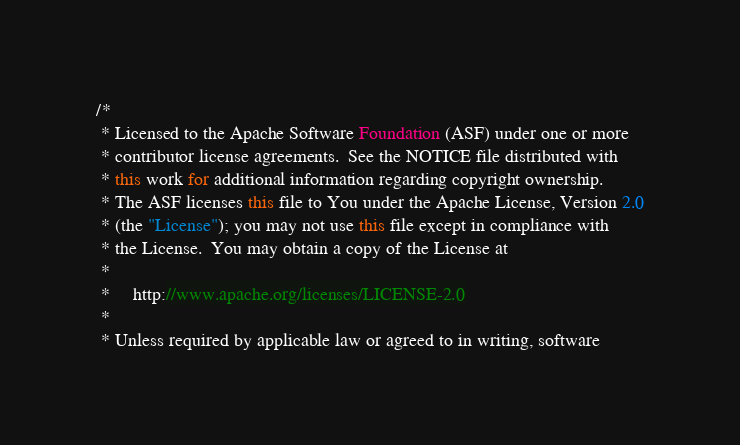Convert code to text. <code><loc_0><loc_0><loc_500><loc_500><_Java_>/*
 * Licensed to the Apache Software Foundation (ASF) under one or more
 * contributor license agreements.  See the NOTICE file distributed with
 * this work for additional information regarding copyright ownership.
 * The ASF licenses this file to You under the Apache License, Version 2.0
 * (the "License"); you may not use this file except in compliance with
 * the License.  You may obtain a copy of the License at
 *
 *     http://www.apache.org/licenses/LICENSE-2.0
 *
 * Unless required by applicable law or agreed to in writing, software</code> 